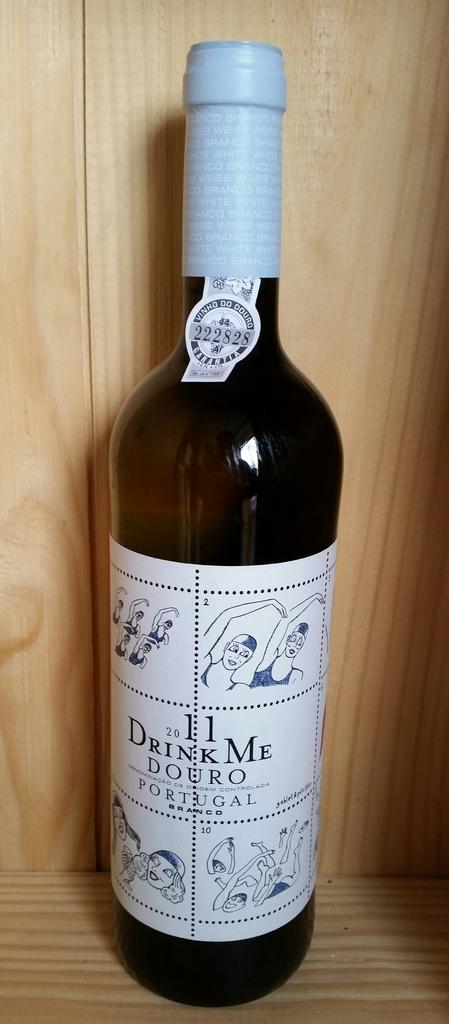From what country is this drink?
Ensure brevity in your answer.  Portugal. What is the brand?
Your answer should be compact. Drink me douro. 